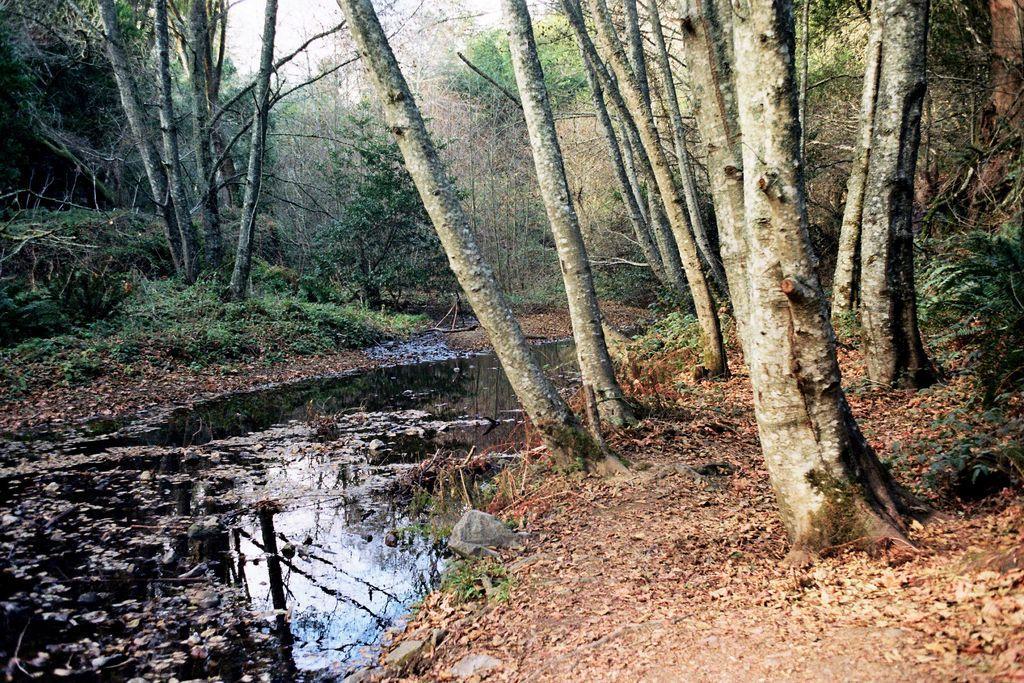In one or two sentences, can you explain what this image depicts? This is water and there are plants. In the background we can see trees and sky. 